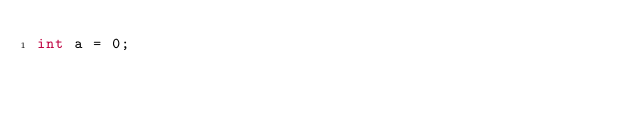Convert code to text. <code><loc_0><loc_0><loc_500><loc_500><_C#_>int a = 0;</code> 